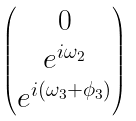<formula> <loc_0><loc_0><loc_500><loc_500>\begin{pmatrix} 0 \\ e ^ { i \omega _ { 2 } } \\ e ^ { i ( \omega _ { 3 } + \phi _ { 3 } ) } \\ \end{pmatrix}</formula> 